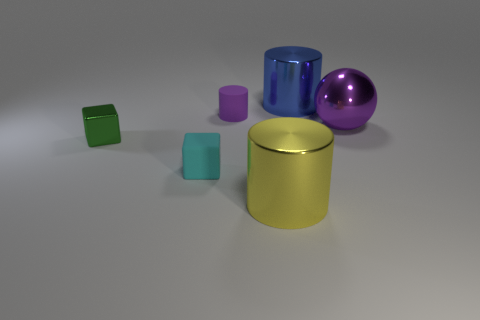Subtract all shiny cylinders. How many cylinders are left? 1 Add 4 purple things. How many objects exist? 10 Subtract all green cubes. How many cubes are left? 1 Subtract all spheres. How many objects are left? 5 Subtract 2 cylinders. How many cylinders are left? 1 Subtract all yellow cylinders. Subtract all purple blocks. How many cylinders are left? 2 Subtract all purple cylinders. How many red blocks are left? 0 Subtract all big cyan matte cubes. Subtract all large purple metal spheres. How many objects are left? 5 Add 4 small cylinders. How many small cylinders are left? 5 Add 3 tiny red rubber cubes. How many tiny red rubber cubes exist? 3 